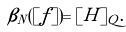Convert formula to latex. <formula><loc_0><loc_0><loc_500><loc_500>\beta _ { N } ( [ f ] ) = [ H ] _ { Q } .</formula> 